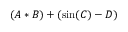Convert formula to latex. <formula><loc_0><loc_0><loc_500><loc_500>( A * B ) + ( \sin ( C ) - D )</formula> 